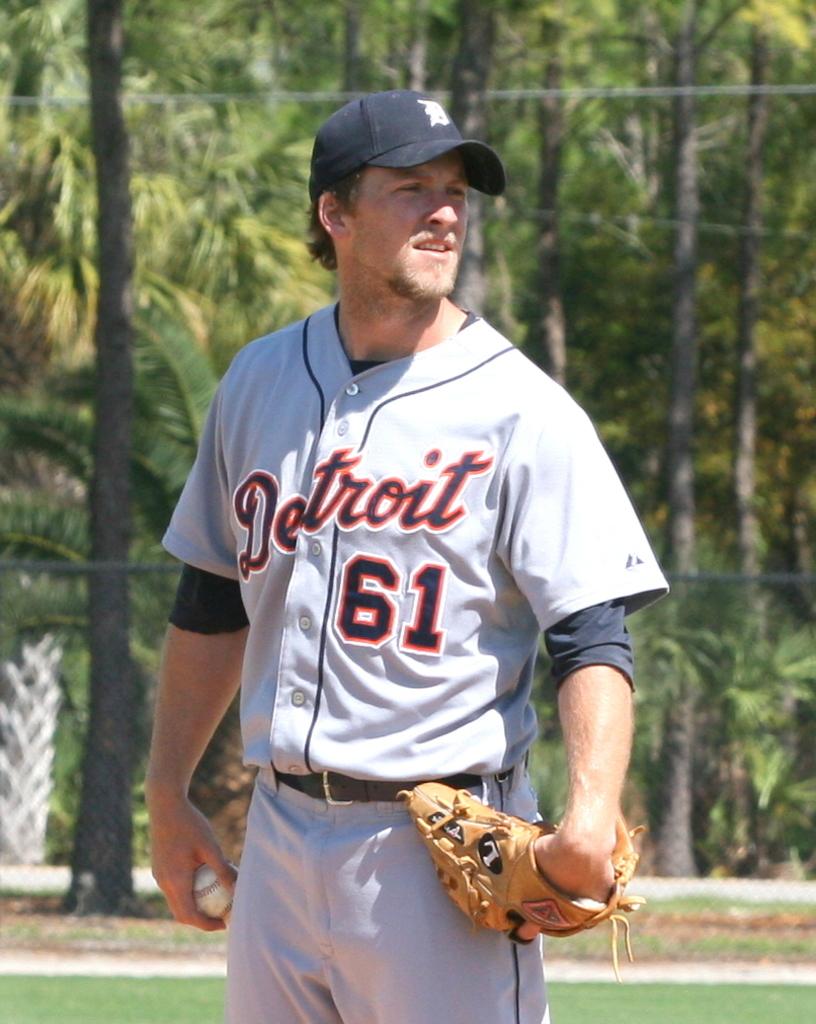What number is on the jersey?
Give a very brief answer. 61. What team is this?
Your answer should be compact. Detroit. 